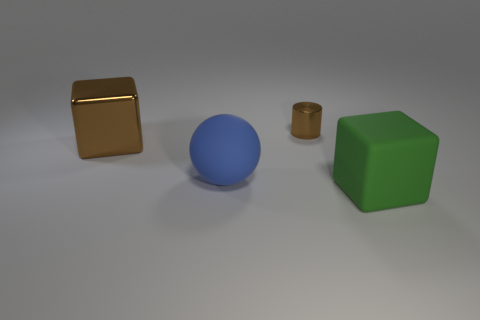Is there a blue rubber thing that is on the right side of the big matte object that is on the left side of the large green object?
Ensure brevity in your answer.  No. Do the large shiny cube and the small metallic object have the same color?
Your answer should be compact. Yes. How many other objects are the same shape as the tiny brown thing?
Ensure brevity in your answer.  0. Is the number of tiny metal cylinders that are right of the metallic cylinder greater than the number of blue matte objects that are in front of the big blue rubber ball?
Offer a terse response. No. Does the block that is behind the big rubber cube have the same size as the rubber thing on the left side of the big green block?
Your answer should be compact. Yes. What shape is the tiny brown metallic object?
Offer a very short reply. Cylinder. The metallic thing that is the same color as the metal block is what size?
Provide a short and direct response. Small. The object that is made of the same material as the large blue ball is what color?
Provide a short and direct response. Green. Do the tiny thing and the big block behind the big matte block have the same material?
Your answer should be very brief. Yes. The big metal object is what color?
Your answer should be very brief. Brown. 